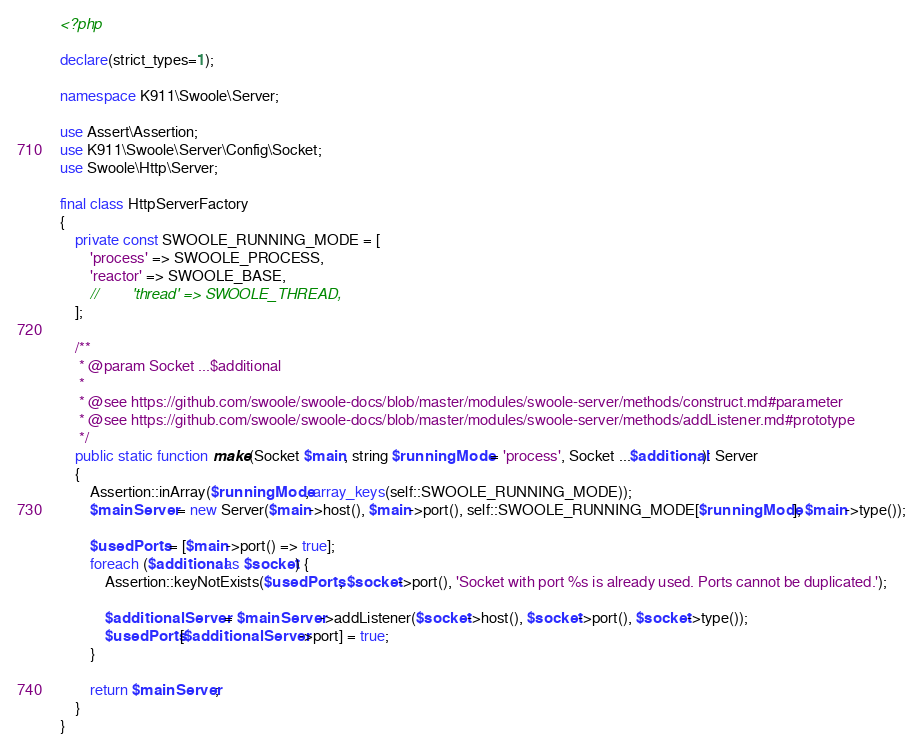Convert code to text. <code><loc_0><loc_0><loc_500><loc_500><_PHP_><?php

declare(strict_types=1);

namespace K911\Swoole\Server;

use Assert\Assertion;
use K911\Swoole\Server\Config\Socket;
use Swoole\Http\Server;

final class HttpServerFactory
{
    private const SWOOLE_RUNNING_MODE = [
        'process' => SWOOLE_PROCESS,
        'reactor' => SWOOLE_BASE,
        //        'thread' => SWOOLE_THREAD,
    ];

    /**
     * @param Socket ...$additional
     *
     * @see https://github.com/swoole/swoole-docs/blob/master/modules/swoole-server/methods/construct.md#parameter
     * @see https://github.com/swoole/swoole-docs/blob/master/modules/swoole-server/methods/addListener.md#prototype
     */
    public static function make(Socket $main, string $runningMode = 'process', Socket ...$additional): Server
    {
        Assertion::inArray($runningMode, array_keys(self::SWOOLE_RUNNING_MODE));
        $mainServer = new Server($main->host(), $main->port(), self::SWOOLE_RUNNING_MODE[$runningMode], $main->type());

        $usedPorts = [$main->port() => true];
        foreach ($additional as $socket) {
            Assertion::keyNotExists($usedPorts, $socket->port(), 'Socket with port %s is already used. Ports cannot be duplicated.');

            $additionalServer = $mainServer->addListener($socket->host(), $socket->port(), $socket->type());
            $usedPorts[$additionalServer->port] = true;
        }

        return $mainServer;
    }
}
</code> 